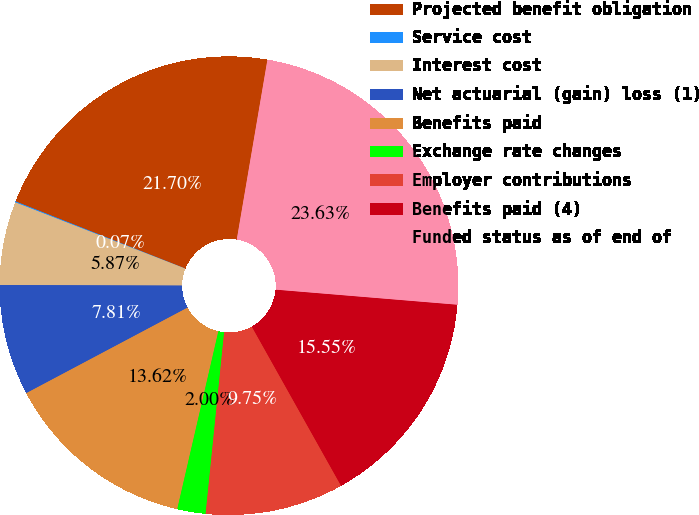Convert chart to OTSL. <chart><loc_0><loc_0><loc_500><loc_500><pie_chart><fcel>Projected benefit obligation<fcel>Service cost<fcel>Interest cost<fcel>Net actuarial (gain) loss (1)<fcel>Benefits paid<fcel>Exchange rate changes<fcel>Employer contributions<fcel>Benefits paid (4)<fcel>Funded status as of end of<nl><fcel>21.7%<fcel>0.07%<fcel>5.87%<fcel>7.81%<fcel>13.62%<fcel>2.0%<fcel>9.75%<fcel>15.55%<fcel>23.63%<nl></chart> 